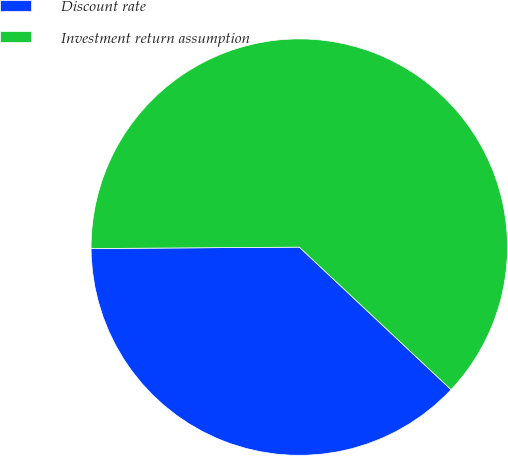Convert chart to OTSL. <chart><loc_0><loc_0><loc_500><loc_500><pie_chart><fcel>Discount rate<fcel>Investment return assumption<nl><fcel>37.89%<fcel>62.11%<nl></chart> 